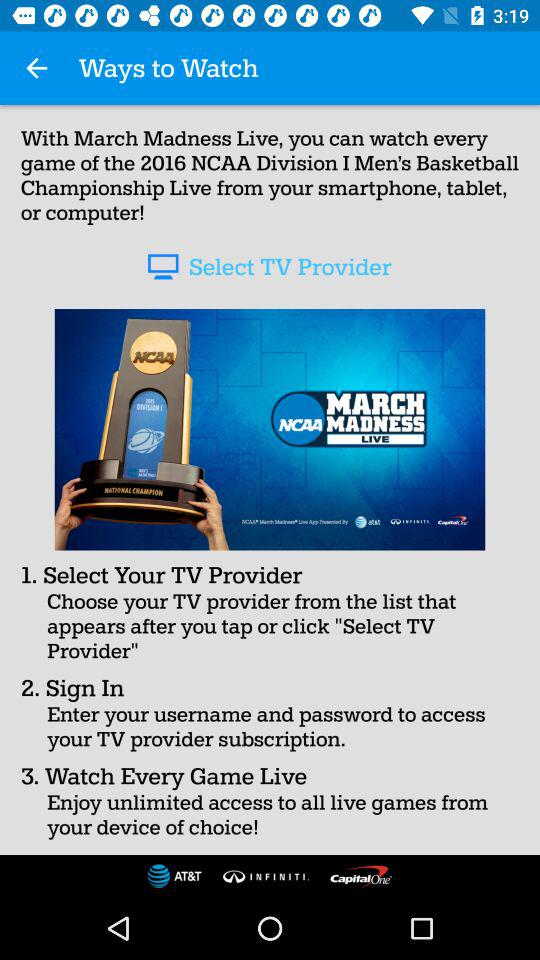How many logos are there on the screen?
Answer the question using a single word or phrase. 4 